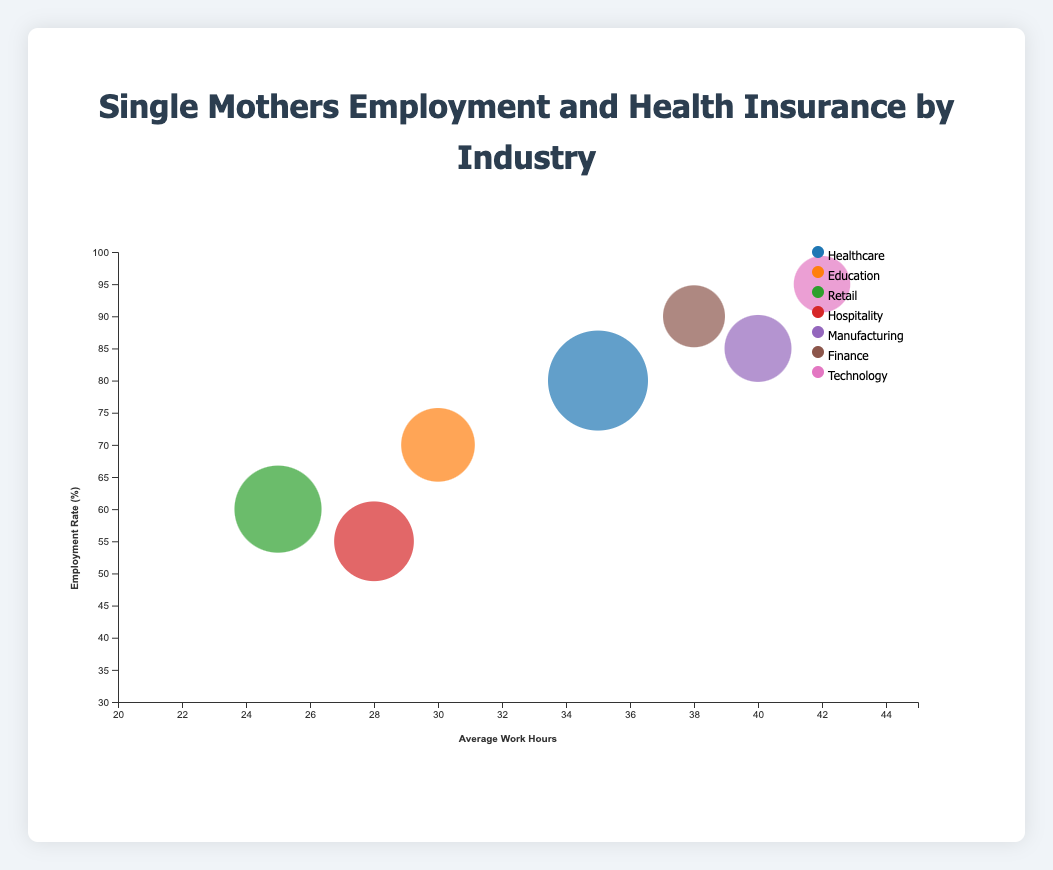What is the title of the figure? The title appears at the top of the chart in larger, bold text. It summarizes the topic of the chart, which is "Single Mothers Employment and Health Insurance by Industry."
Answer: Single Mothers Employment and Health Insurance by Industry Which industry has the highest employment rate? By examining the vertical axis (Employment Rate) and identifying the highest circle, it can be seen that the Technology sector leads with an employment rate of 95%.
Answer: Technology What are the average work hours in the Manufacturing industry? Look along the horizontal axis (Average Work Hours) for the bubble labeled "Manufacturing," which is positioned at 40.
Answer: 40 Which industry has the lowest health insurance coverage and what is the percentage? By checking the tooltip information or looking at the vertical position along the Health Insurance Coverage percentage, the Hospitality industry has the lowest at 35%.
Answer: Hospitality, 35% Which industry has the most single mothers? The size of the bubbles represents the number of single mothers. The largest bubble is labeled “Healthcare,” indicating it has the highest number of single mothers at 30,000.
Answer: Healthcare How does the employment rate compare between the Finance and Retail industries? Compare the vertical positions of the bubbles. Finance is at 90% while Retail stands at 60%, indicating Finance has a higher employment rate.
Answer: Finance has a higher employment rate What is the average number of working hours across all industries displayed? Sum the average work hours of all industries (35+30+25+28+40+38+42) which equals 238, then divide by the number of industries (7), resulting in 238/7 = 34.
Answer: 34 Which industry has a higher health insurance coverage: Education or Manufacturing? Compare the vertical locations along the Health Insurance Coverage. Manufacturing stands at 80%, while Education is at 65%.
Answer: Manufacturing How many industries have an employment rate above 75%? Identify which bubbles are above the 75% mark on the vertical Employment Rate axis. Healthcare, Manufacturing, Finance, and Technology meet this criteria, totaling 4 industries.
Answer: 4 What is the difference in health insurance coverage between the industries with the highest and lowest coverage? Find the highest and lowest coverage percentages (Technology at 90% and Hospitality at 35%). Subtract the lower from the higher, leading to 90% - 35% = 55%.
Answer: 55% 